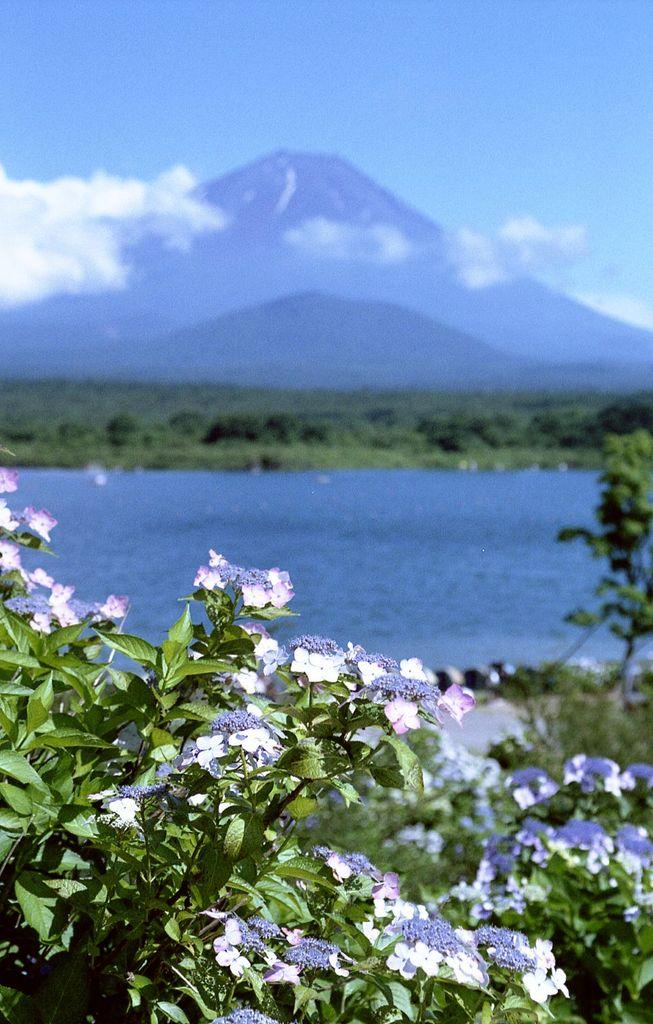What type of plants are at the bottom of the image? There are flower plants at the bottom of the image. What is located in the middle of the image? There is a pond in the middle of the image. What other natural elements can be seen in the image? There are trees in the image. What is visible at the back of the image? There are hills at the back side of the image. What is visible at the top of the image? The sky is visible at the top of the image. What type of square object can be seen floating in the pond in the image? There is no square object present in the image; the pond is surrounded by natural elements such as plants and trees. Is there any quicksand visible in the image? No, there is no quicksand present in the image. 